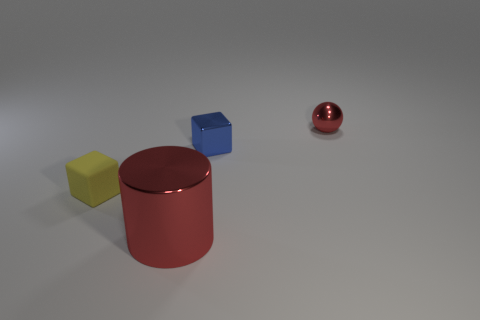How many tiny objects are both on the right side of the yellow rubber object and in front of the small metallic sphere?
Offer a terse response. 1. There is a red metallic object behind the big cylinder; what number of yellow matte things are behind it?
Give a very brief answer. 0. How many objects are either objects behind the small yellow rubber object or things right of the yellow thing?
Provide a short and direct response. 3. There is another tiny thing that is the same shape as the small matte thing; what material is it?
Offer a terse response. Metal. How many things are either red things that are to the right of the red metal cylinder or large rubber cubes?
Offer a terse response. 1. There is a big red object that is made of the same material as the small red sphere; what is its shape?
Provide a short and direct response. Cylinder. What number of other objects are the same shape as the matte object?
Your answer should be very brief. 1. What is the yellow block made of?
Keep it short and to the point. Rubber. Is the color of the small matte object the same as the metallic thing that is left of the tiny blue object?
Offer a terse response. No. How many blocks are metal things or large shiny objects?
Your response must be concise. 1. 